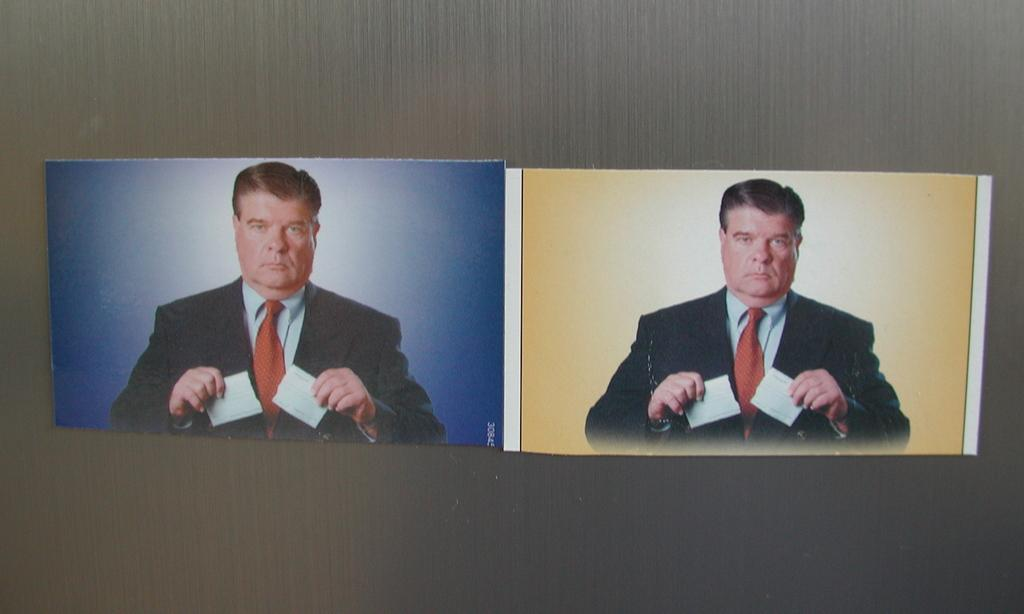What is depicted in the two photos in the image? The two photos in the image are of a person. What is the person holding in the image? The person is holding papers. How are the photos and papers arranged in the image? The photos and papers are attached to a grey color board. What type of string is used to attach the photos and papers to the board? There is no mention of string in the image; the photos and papers are simply attached to the grey color board. 